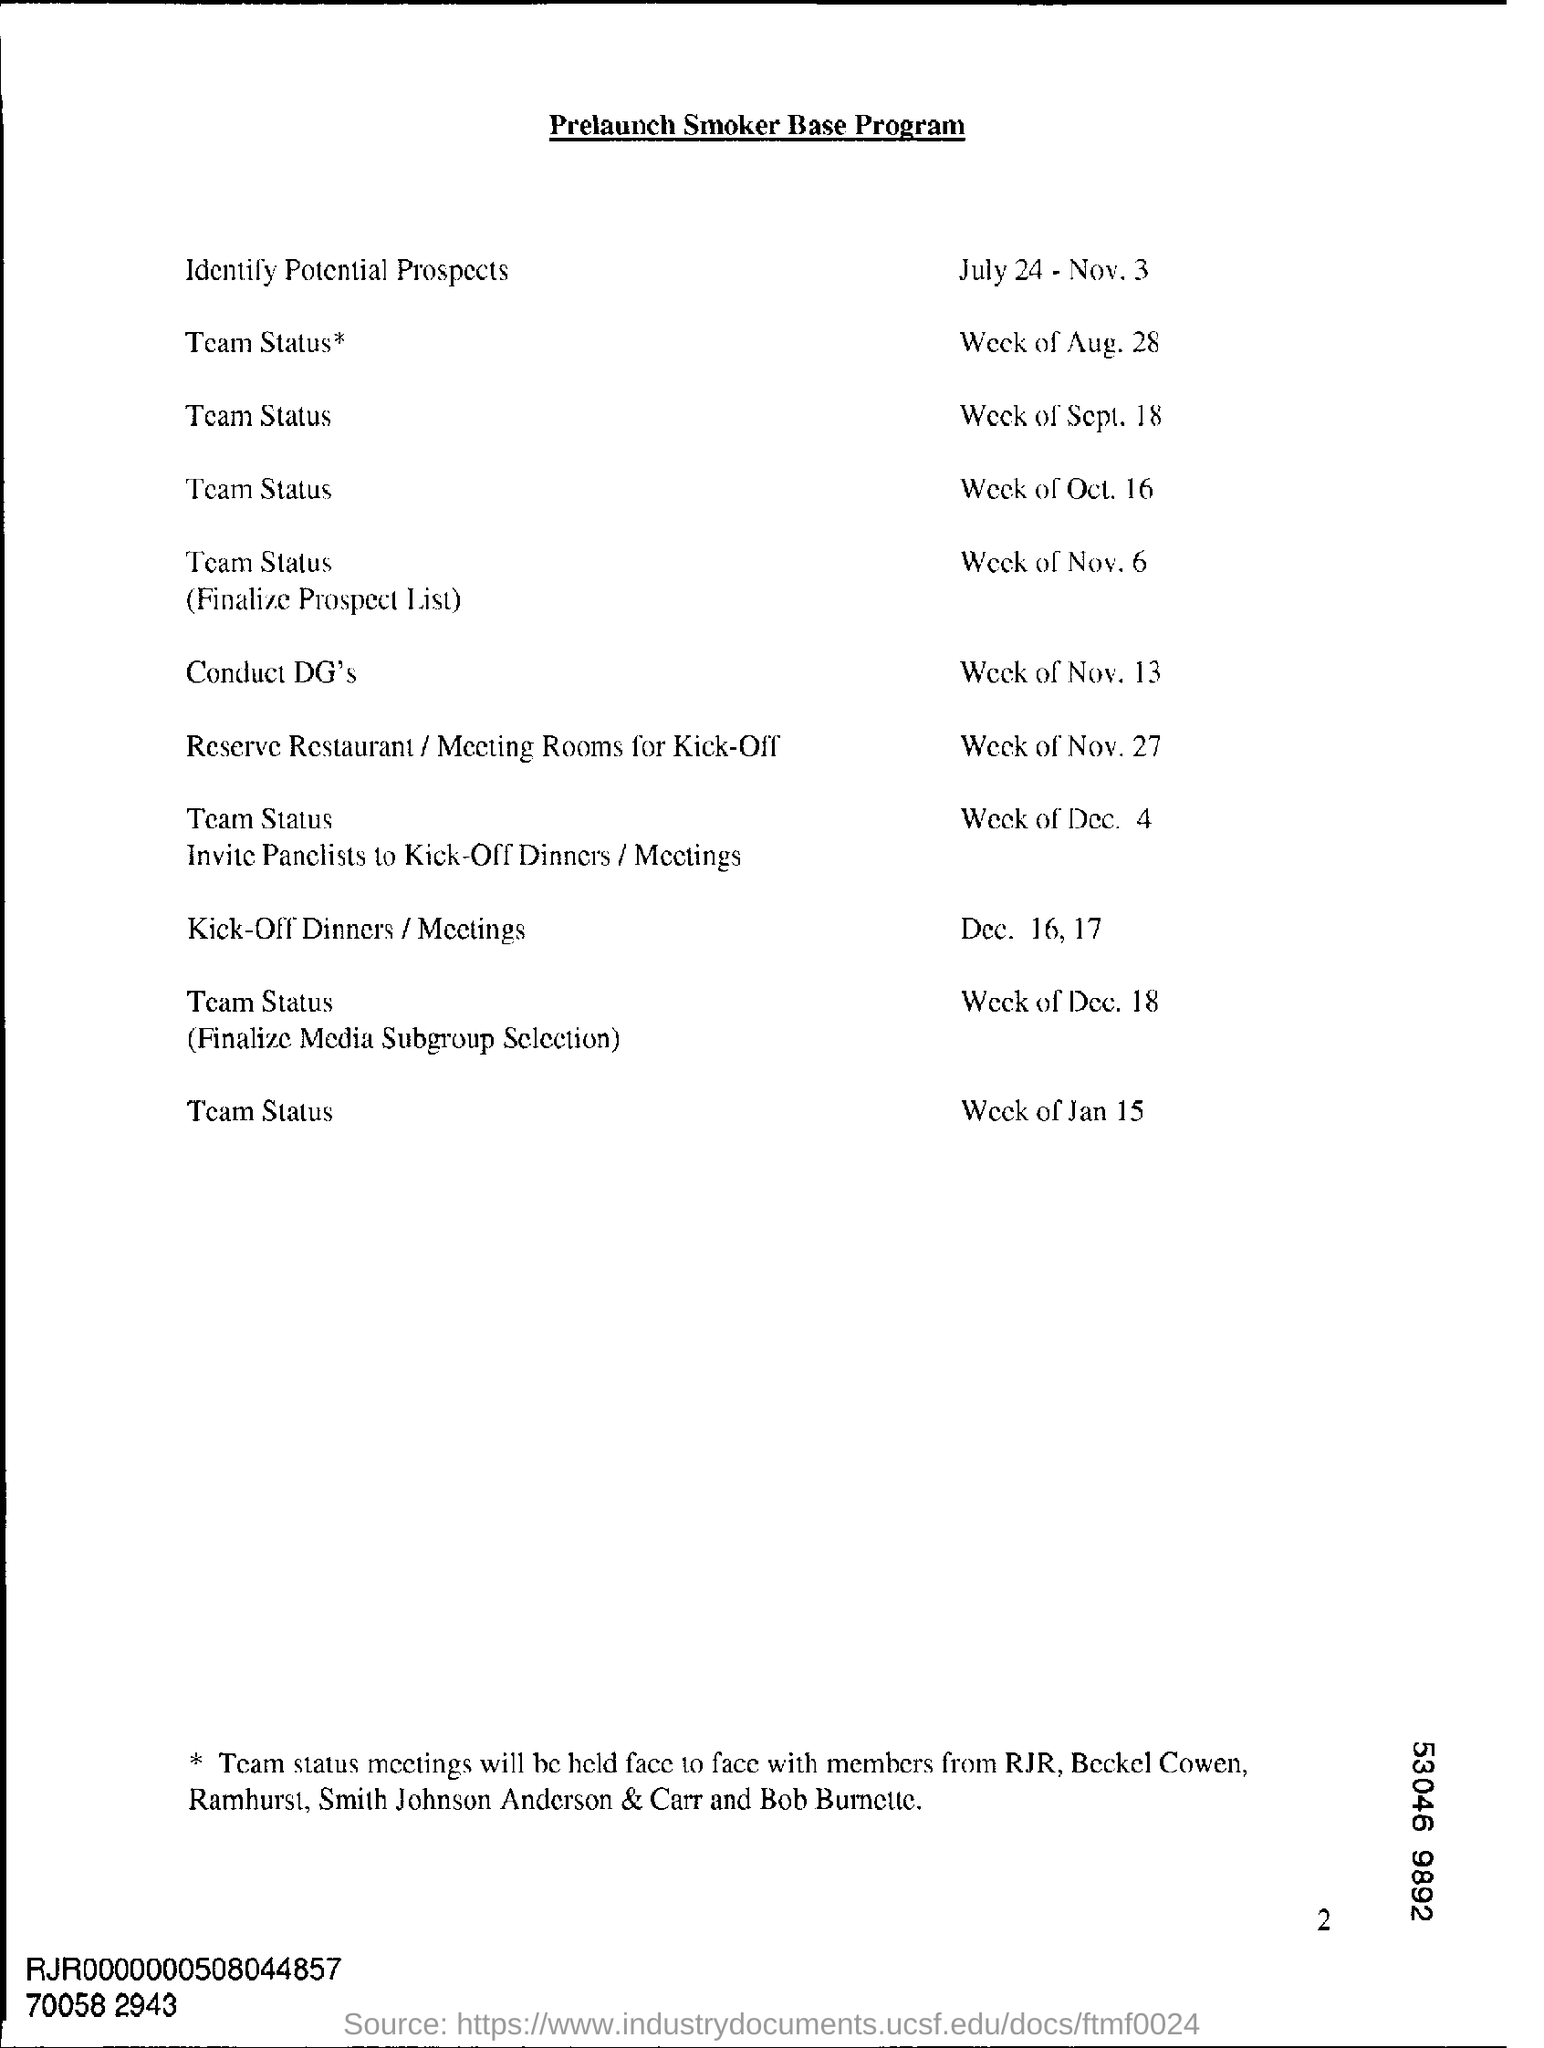What is the heading of the document?
Offer a terse response. Prelaunch Smoker Base Program. What is the date mentioned for Identify Potential Prospects?
Provide a succinct answer. July 24 Nov, 3. 